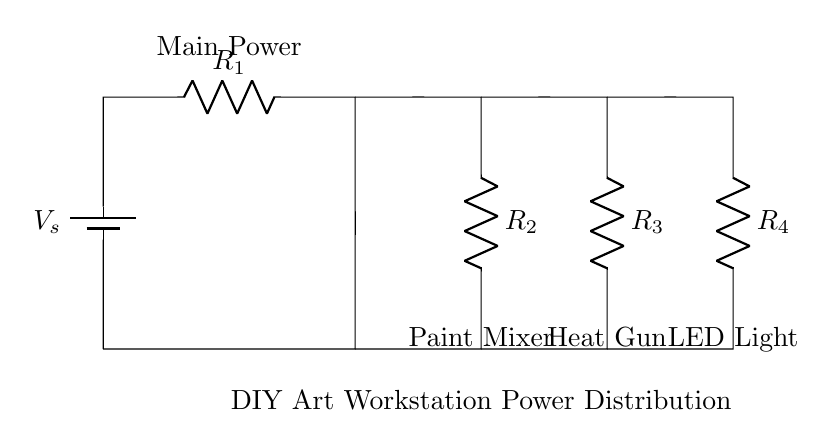What is the total resistance of the circuit? The total resistance can be found using the formula for parallel resistors. In this circuit, R2, R3, and R4 are in parallel. The total resistance is calculated using the formula: 1/R_total = 1/R2 + 1/R3 + 1/R4. First, find the equivalent resistance of these three resistors, and then add R1 to it to get the total resistance.
Answer: R_total What does the battery represent in this circuit? The battery represents the power source of the circuit. It provides the voltage that drives current through the resistors and powers the tools in the DIY workstation.
Answer: Power source Which device gets the most current? The current divider principle states that the current through each branch is inversely proportional to its resistance. The device with the smallest resistance will get the most current. Therefore, the current will be greatest through the resistor with the lowest resistance among R2, R3, and R4. Assuming equal resistances, they would share the current equally.
Answer: Depends on resistance What is the main function of a current divider in this circuit? The main function of a current divider is to distribute the total current from the power source into multiple branches according to the resistances in those branches. Each branch receives a portion of the total current, allowing different tools to operate simultaneously.
Answer: Distribute current What happens if one of the resistors fails? If one of the resistors fails (assuming it opens circuit), it will break the path for current in that branch. This will alter the current distribution among the remaining branches, as the total current will now only flow through the other resistors. The current through the remaining devices will increase while the failed device receives no current at all.
Answer: Breaks current path What tools are being powered in this circuit? The circuit diagram indicates that the devices being powered are the paint mixer, heat gun, and LED light. These tools are connected in parallel and will receive power from the battery accordingly.
Answer: Paint mixer, heat gun, LED light 